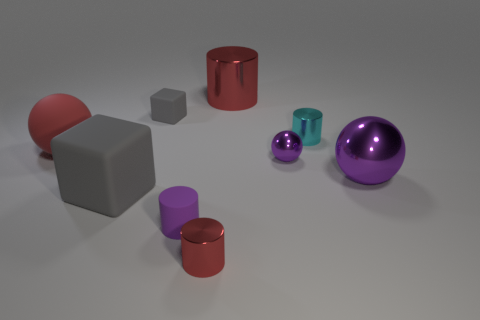What size is the red ball that is the same material as the large gray object?
Provide a succinct answer. Large. Is there another cylinder of the same color as the large shiny cylinder?
Your response must be concise. Yes. What number of objects are tiny objects that are in front of the purple cylinder or large shiny spheres?
Give a very brief answer. 2. Is the tiny red thing made of the same material as the gray block behind the big metallic ball?
Offer a terse response. No. What is the size of the matte thing that is the same color as the tiny matte block?
Ensure brevity in your answer.  Large. Are there any other objects made of the same material as the small cyan thing?
Ensure brevity in your answer.  Yes. What number of things are either gray things in front of the small cyan cylinder or red things that are behind the big gray cube?
Provide a succinct answer. 3. There is a large red rubber object; does it have the same shape as the large gray rubber thing in front of the tiny cyan metallic object?
Provide a short and direct response. No. How many other things are there of the same shape as the tiny purple metallic object?
Offer a terse response. 2. What number of things are either tiny green rubber blocks or small rubber cylinders?
Your answer should be compact. 1. 